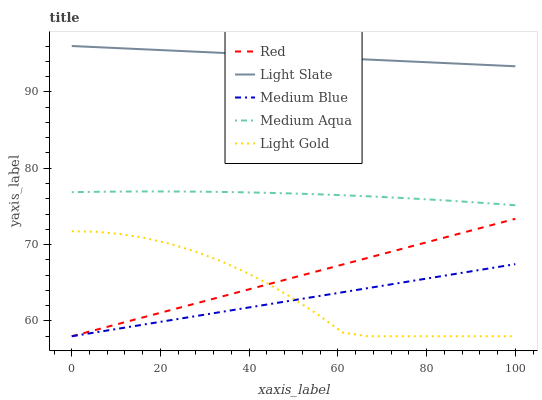Does Medium Blue have the minimum area under the curve?
Answer yes or no. Yes. Does Light Slate have the maximum area under the curve?
Answer yes or no. Yes. Does Medium Aqua have the minimum area under the curve?
Answer yes or no. No. Does Medium Aqua have the maximum area under the curve?
Answer yes or no. No. Is Medium Blue the smoothest?
Answer yes or no. Yes. Is Light Gold the roughest?
Answer yes or no. Yes. Is Medium Aqua the smoothest?
Answer yes or no. No. Is Medium Aqua the roughest?
Answer yes or no. No. Does Light Gold have the lowest value?
Answer yes or no. Yes. Does Medium Aqua have the lowest value?
Answer yes or no. No. Does Light Slate have the highest value?
Answer yes or no. Yes. Does Medium Aqua have the highest value?
Answer yes or no. No. Is Red less than Light Slate?
Answer yes or no. Yes. Is Light Slate greater than Medium Blue?
Answer yes or no. Yes. Does Medium Blue intersect Light Gold?
Answer yes or no. Yes. Is Medium Blue less than Light Gold?
Answer yes or no. No. Is Medium Blue greater than Light Gold?
Answer yes or no. No. Does Red intersect Light Slate?
Answer yes or no. No. 